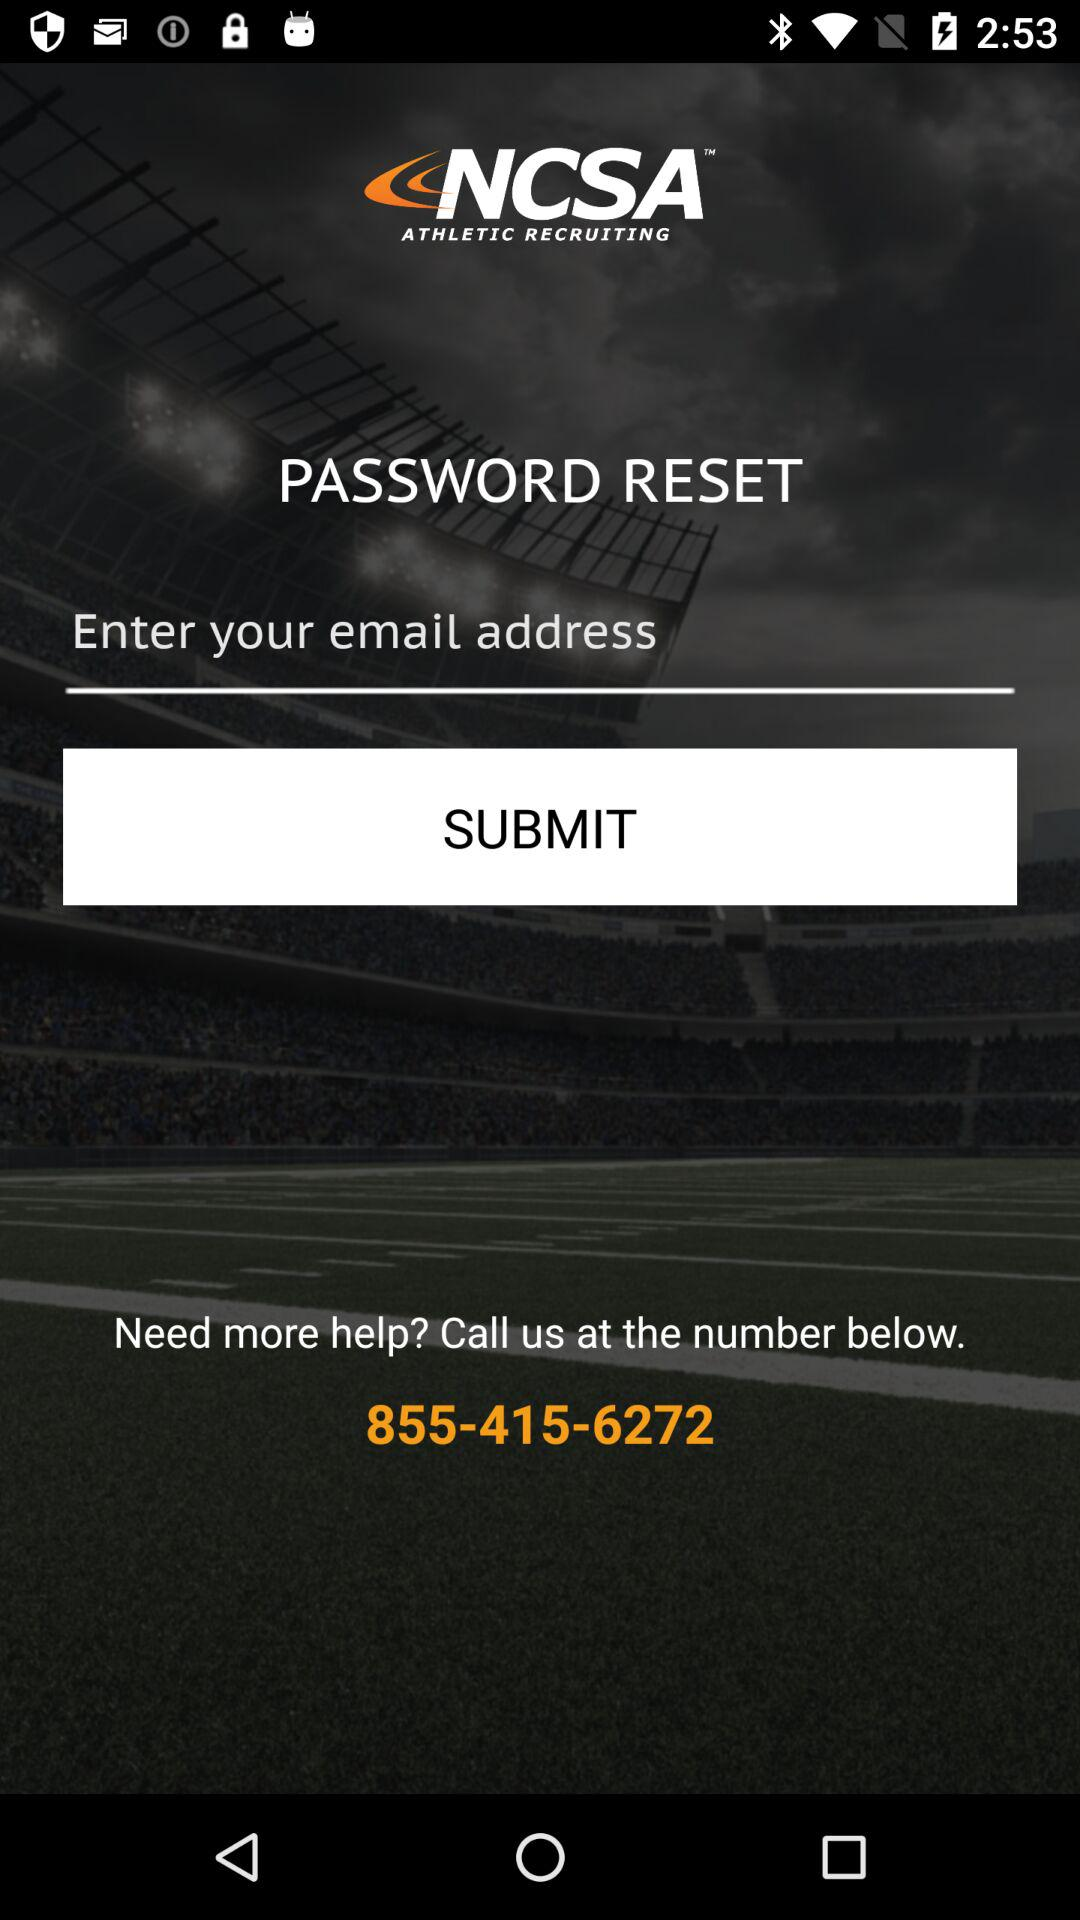What is the app's name? The app's name is "NCSA ATHLETIC RECRUITING". 